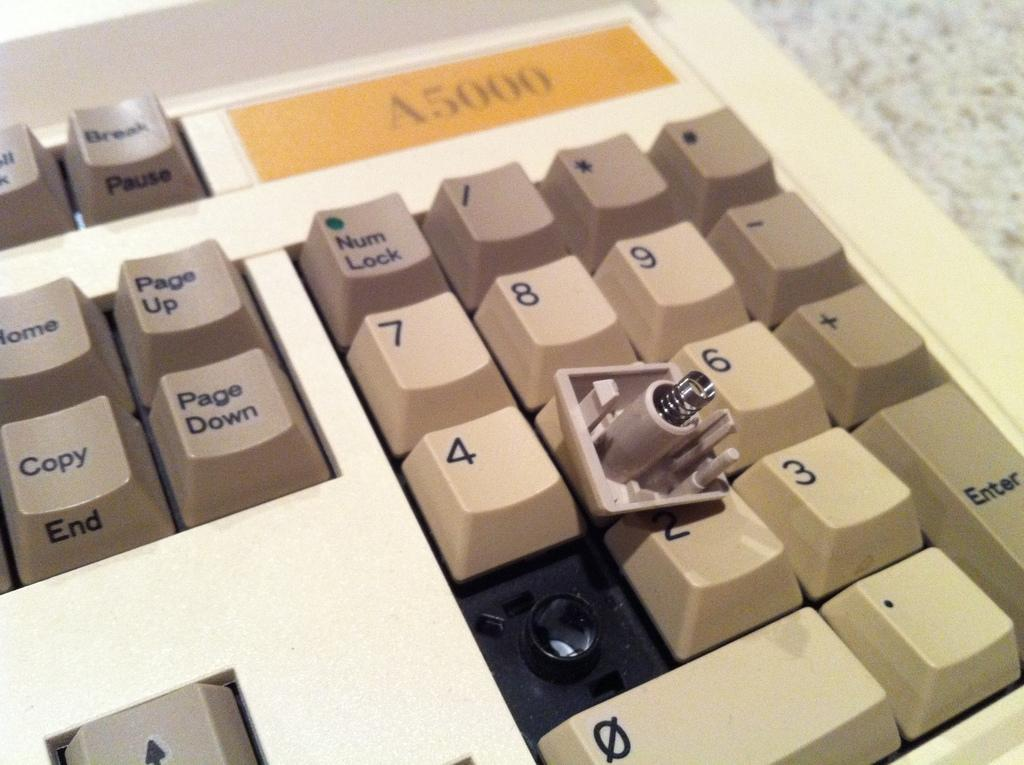<image>
Share a concise interpretation of the image provided. An older keyboard that is missing with number 1. 